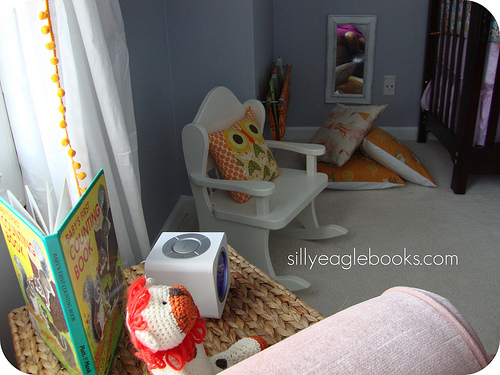<image>
Is the sheet out next to the rocking chair? No. The sheet out is not positioned next to the rocking chair. They are located in different areas of the scene. Is there a book under the curtain? No. The book is not positioned under the curtain. The vertical relationship between these objects is different. Is there a pillow above the floor? Yes. The pillow is positioned above the floor in the vertical space, higher up in the scene. 